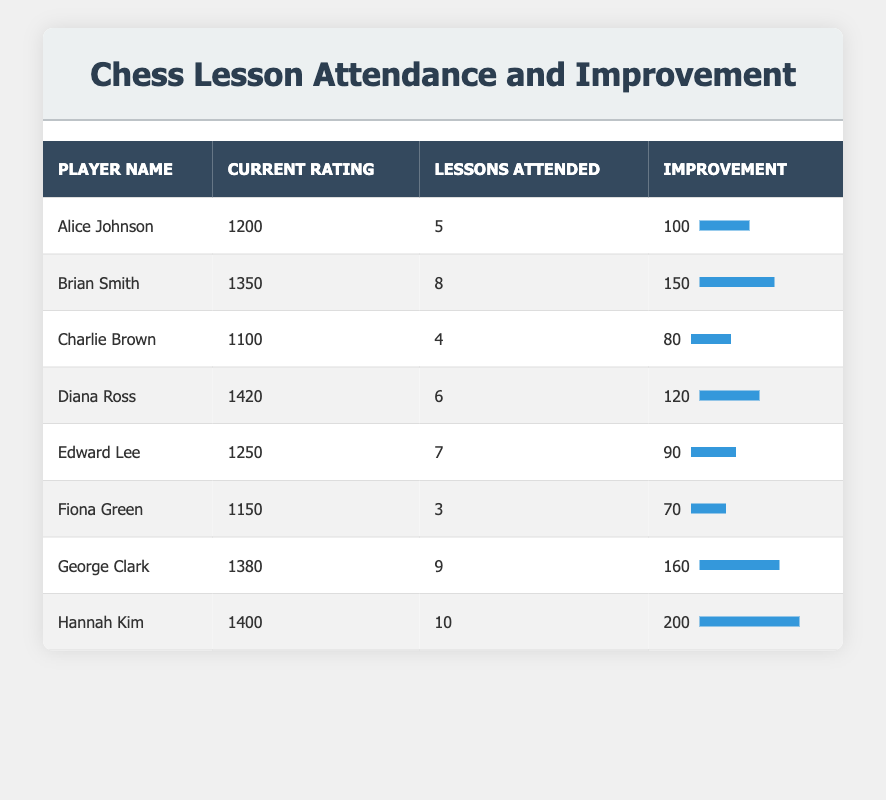What is the current rating of Diana Ross? Looking at the table, we can see that Diana Ross has a current rating listed under the "Current Rating" column, which is 1420.
Answer: 1420 Which player attended the most lessons? Upon examining the "Lessons Attended" column, we find that Hannah Kim attended 10 lessons, which is the highest among all players listed.
Answer: Hannah Kim What is the total improvement of players who attended more than 6 lessons? We need to consider players with more than 6 lessons: Brian Smith (150), George Clark (160), and Hannah Kim (200). Adding these gives us a total improvement of 150 + 160 + 200 = 510.
Answer: 510 Is it true that Alice Johnson attended more lessons than Fiona Green? Alice attended 5 lessons, while Fiona attended 3 lessons. Since 5 is greater than 3, the statement is true.
Answer: Yes Which player showed the greatest improvement, and what was their improvement? By examining the "Improvement" column, we see that Hannah Kim has the highest improvement value of 200, indicating she showed the greatest improvement over time.
Answer: Hannah Kim, 200 What is the average current rating of players who attended 8 lessons or more? The players who attended 8 or more lessons are Brian Smith (1350), George Clark (1380), and Hannah Kim (1400). Calculating the average: (1350 + 1380 + 1400) / 3 = 1376.67.
Answer: 1376.67 How many players improved their ratings by more than 100 points? Reviewing the "Improvement" column, we find that Alice Johnson (100), Brian Smith (150), Diana Ross (120), George Clark (160), and Hannah Kim (200) all improved by more than 100 points. This totals to 5 players.
Answer: 5 What is the difference in current rating between the player with the highest and the lowest rating? The player with the highest rating is Hannah Kim at 1400, and the lowest rating is Charlie Brown at 1100. The difference is 1400 - 1100 = 300.
Answer: 300 